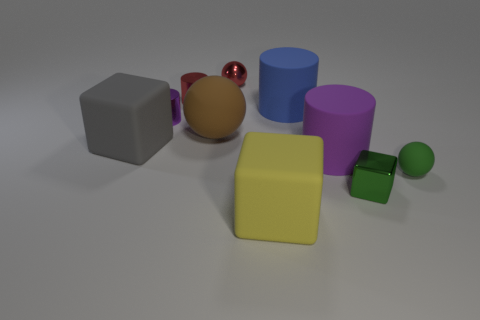Is the number of blue rubber cylinders that are behind the blue rubber cylinder greater than the number of brown rubber objects?
Offer a very short reply. No. What shape is the purple thing to the right of the matte ball behind the large rubber cylinder in front of the small purple cylinder?
Your answer should be compact. Cylinder. Does the rubber sphere that is to the right of the blue cylinder have the same size as the metallic block?
Keep it short and to the point. Yes. There is a small thing that is to the right of the red ball and on the left side of the small matte thing; what is its shape?
Offer a very short reply. Cube. There is a metallic sphere; does it have the same color as the cylinder that is to the right of the blue matte thing?
Ensure brevity in your answer.  No. There is a block that is left of the red metal thing that is right of the small metal cylinder that is behind the small purple cylinder; what is its color?
Provide a succinct answer. Gray. The other big matte thing that is the same shape as the large gray object is what color?
Offer a terse response. Yellow. Is the number of large things that are behind the big gray rubber cube the same as the number of large green cylinders?
Provide a succinct answer. No. What number of spheres are either green rubber things or large yellow matte things?
Your answer should be very brief. 1. There is a big ball that is the same material as the blue cylinder; what color is it?
Keep it short and to the point. Brown. 